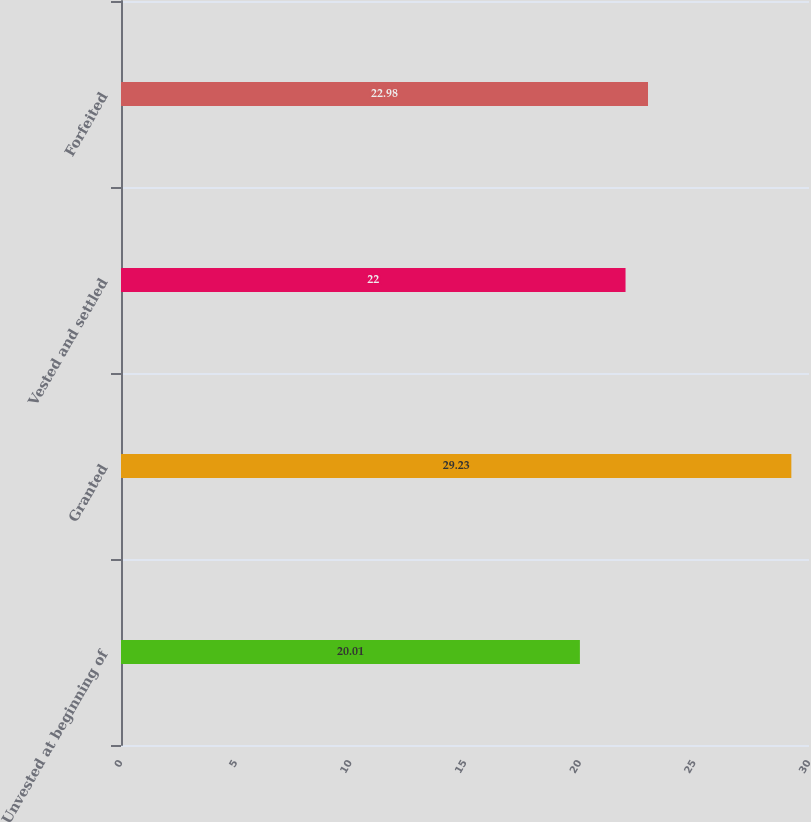<chart> <loc_0><loc_0><loc_500><loc_500><bar_chart><fcel>Unvested at beginning of<fcel>Granted<fcel>Vested and settled<fcel>Forfeited<nl><fcel>20.01<fcel>29.23<fcel>22<fcel>22.98<nl></chart> 